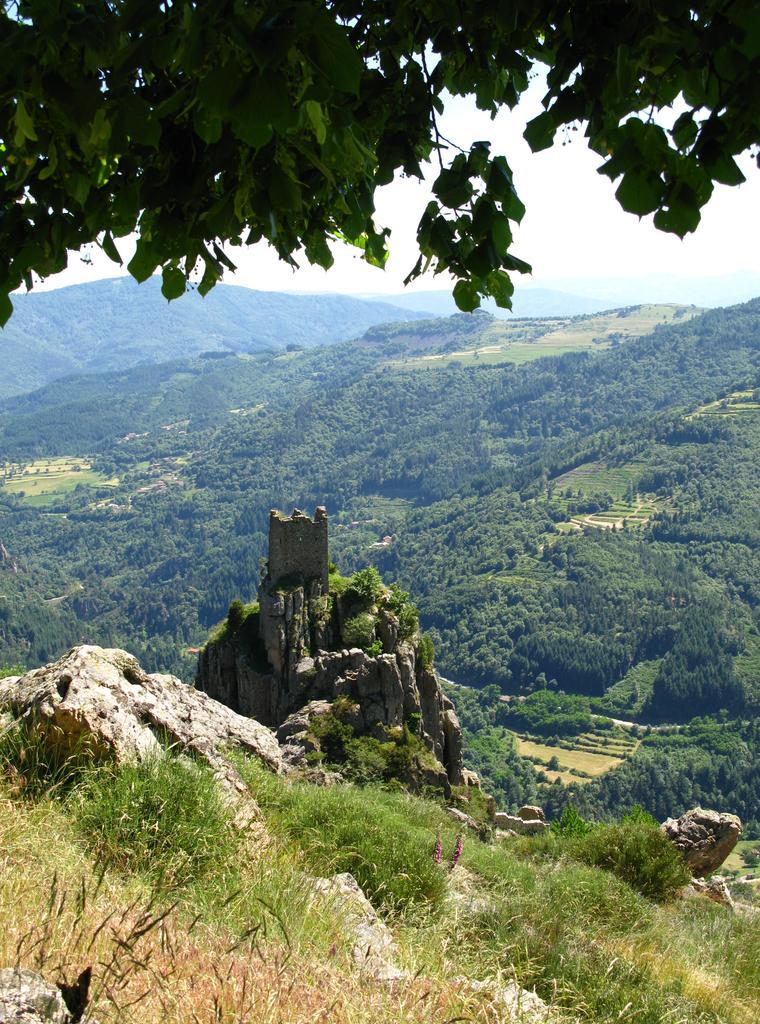How would you summarize this image in a sentence or two? In this picture we can see grass, hills and trees. In the background of the image we can see the sky. At the top of the image we can see leaves and stems. 